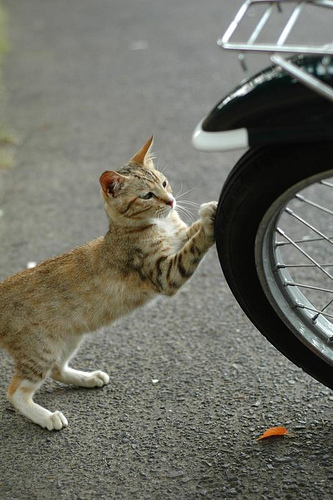<image>
Is the cat pushing to the left of the bike tire? Yes. From this viewpoint, the cat pushing is positioned to the left side relative to the bike tire. 